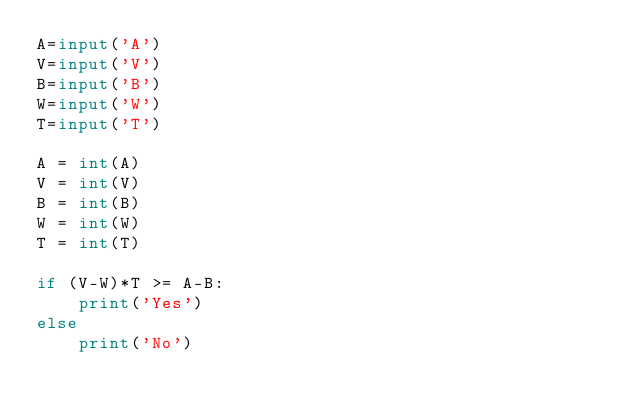<code> <loc_0><loc_0><loc_500><loc_500><_Python_>A=input('A')
V=input('V')
B=input('B')
W=input('W')
T=input('T')

A = int(A)
V = int(V)
B = int(B)
W = int(W)
T = int(T)

if (V-W)*T >= A-B:
	print('Yes')
else
	print('No')</code> 